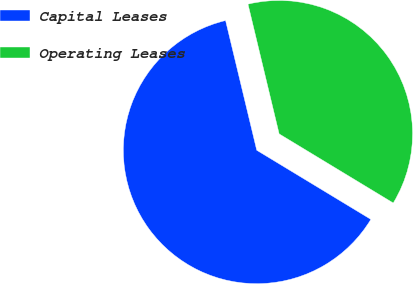Convert chart. <chart><loc_0><loc_0><loc_500><loc_500><pie_chart><fcel>Capital Leases<fcel>Operating Leases<nl><fcel>62.58%<fcel>37.42%<nl></chart> 